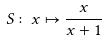Convert formula to latex. <formula><loc_0><loc_0><loc_500><loc_500>S \colon x \mapsto \frac { x } { x + 1 }</formula> 